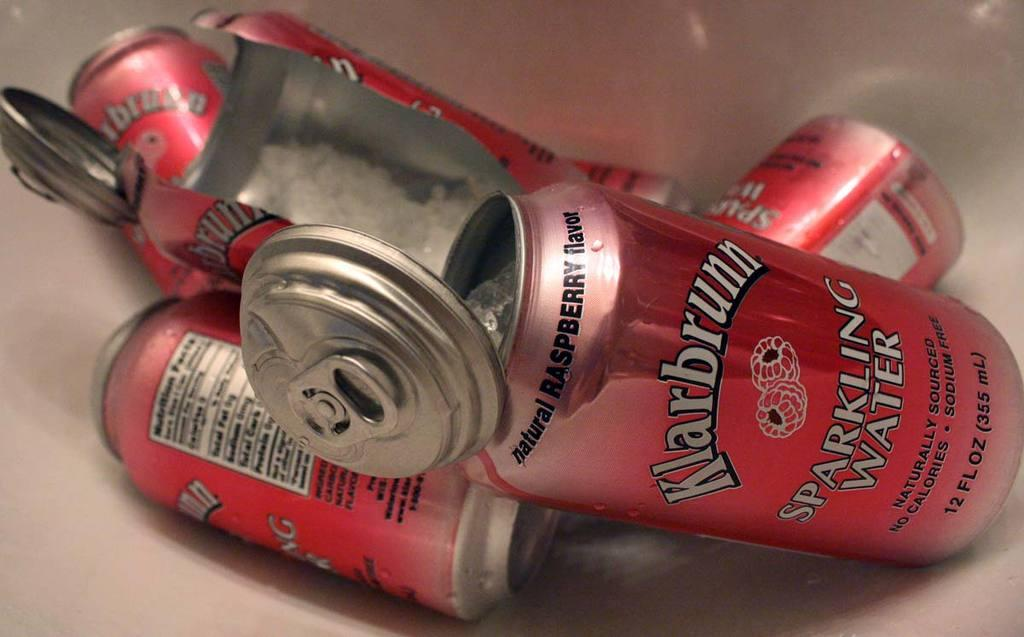<image>
Provide a brief description of the given image. A can that is red that says natural raspberry flavor. 